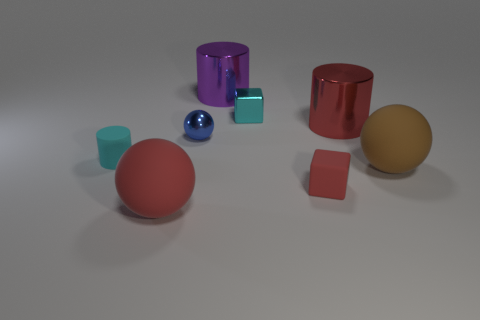There is a big matte ball that is behind the matte sphere left of the tiny blue metallic object; what is its color?
Offer a very short reply. Brown. Is the color of the rubber block the same as the tiny cube behind the large brown rubber sphere?
Make the answer very short. No. What is the size of the brown thing that is the same material as the cyan cylinder?
Give a very brief answer. Large. There is a metal thing that is the same color as the tiny matte cube; what size is it?
Provide a succinct answer. Large. Is the color of the small shiny block the same as the tiny matte cylinder?
Provide a succinct answer. Yes. There is a rubber thing to the left of the big matte sphere in front of the tiny red object; is there a blue shiny sphere that is to the right of it?
Ensure brevity in your answer.  Yes. How many cyan matte things have the same size as the blue sphere?
Make the answer very short. 1. Do the red sphere that is in front of the large red shiny object and the matte thing to the right of the red shiny cylinder have the same size?
Keep it short and to the point. Yes. There is a rubber object that is to the right of the cyan cylinder and behind the small red matte object; what shape is it?
Offer a very short reply. Sphere. Are there any metal cylinders that have the same color as the tiny metal ball?
Provide a succinct answer. No. 